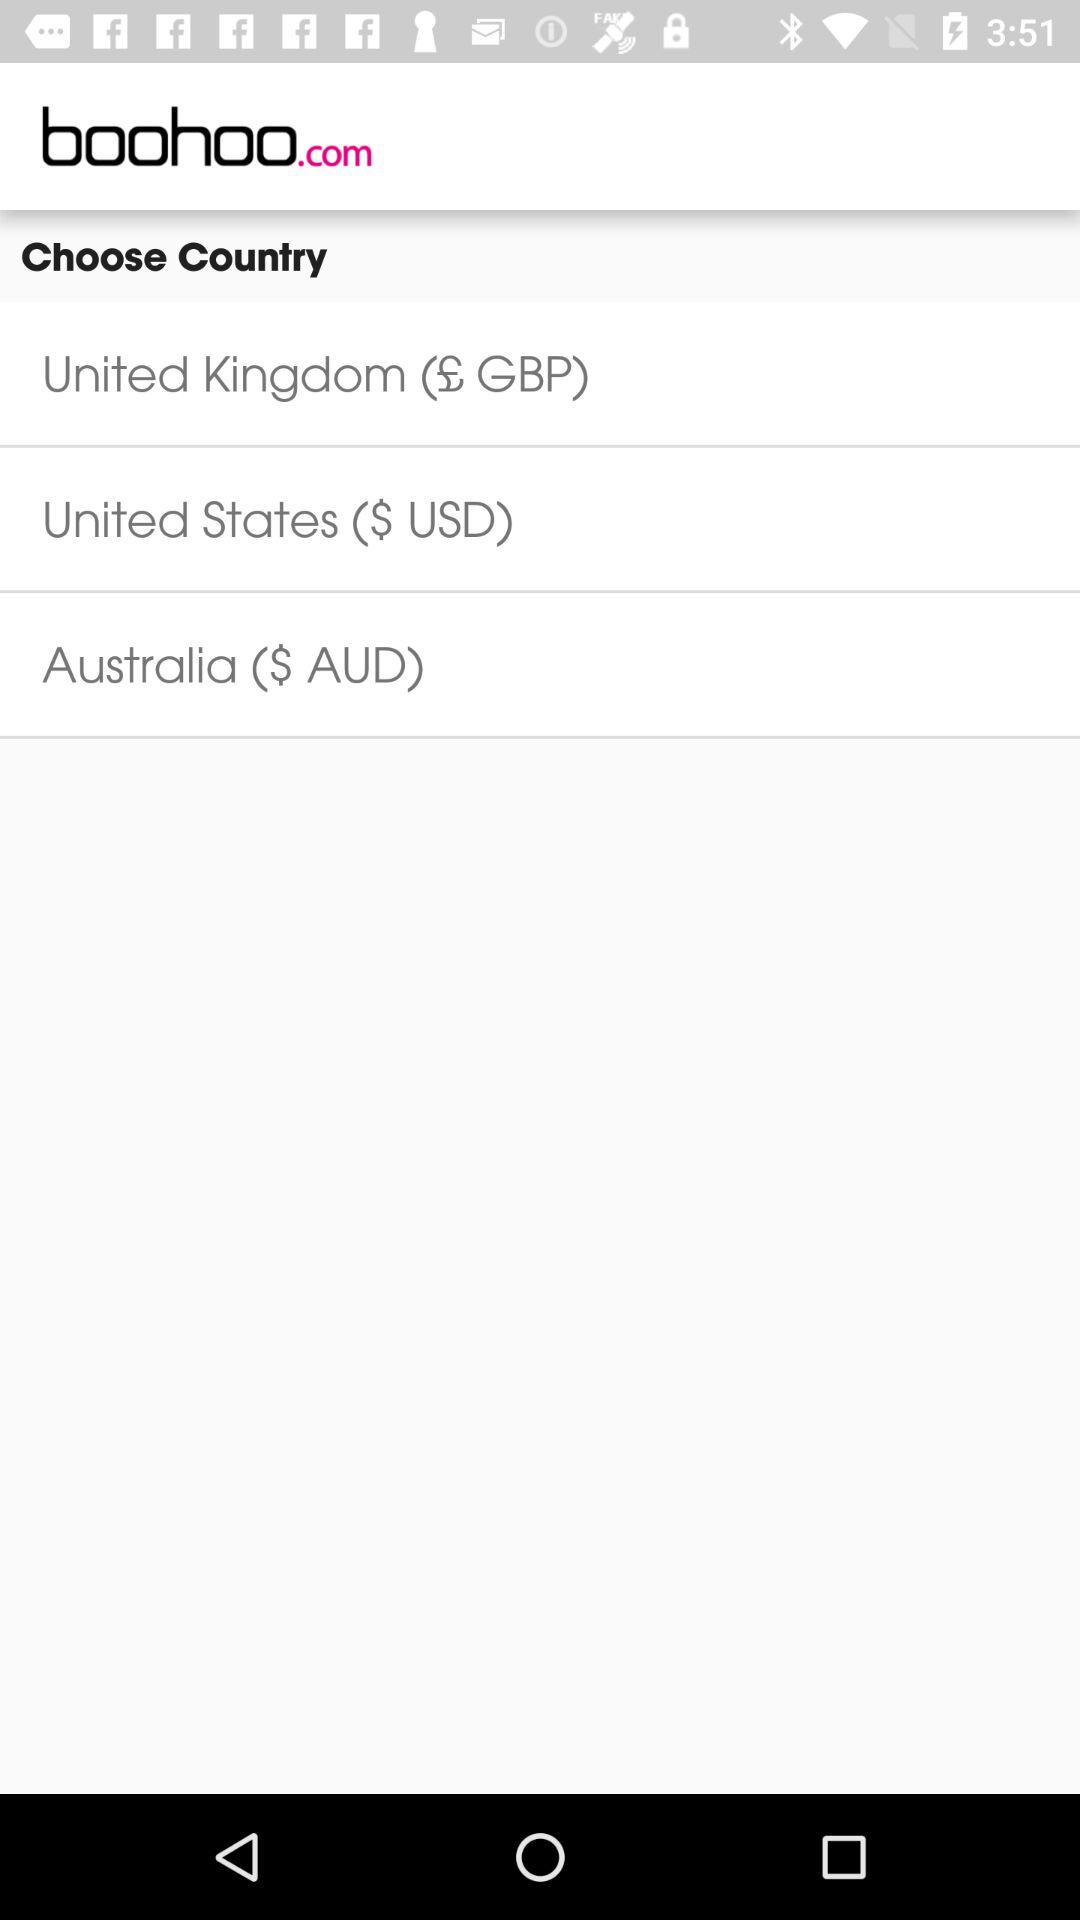What is the currency of Australia? The currency of Australia is AUD. 